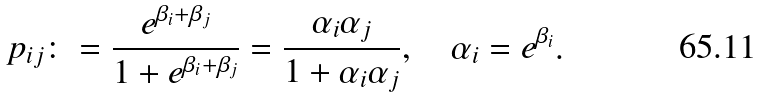Convert formula to latex. <formula><loc_0><loc_0><loc_500><loc_500>p _ { i j } & \colon = \frac { e ^ { \beta _ { i } + \beta _ { j } } } { 1 + e ^ { \beta _ { i } + \beta _ { j } } } = \frac { \alpha _ { i } \alpha _ { j } } { 1 + \alpha _ { i } \alpha _ { j } } , \quad \alpha _ { i } = e ^ { \beta _ { i } } .</formula> 